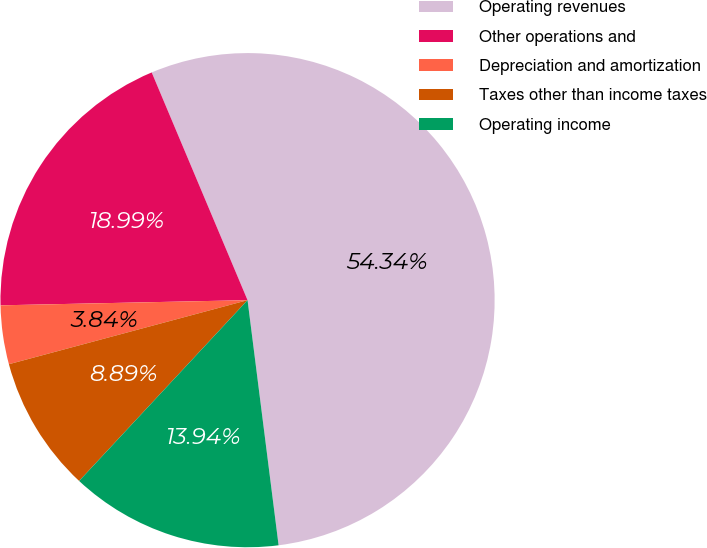<chart> <loc_0><loc_0><loc_500><loc_500><pie_chart><fcel>Operating revenues<fcel>Other operations and<fcel>Depreciation and amortization<fcel>Taxes other than income taxes<fcel>Operating income<nl><fcel>54.33%<fcel>18.99%<fcel>3.84%<fcel>8.89%<fcel>13.94%<nl></chart> 